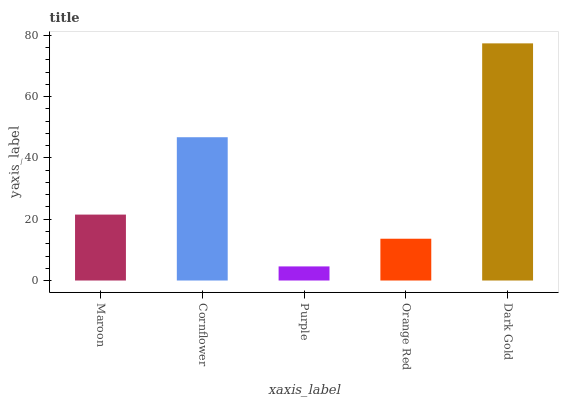Is Purple the minimum?
Answer yes or no. Yes. Is Dark Gold the maximum?
Answer yes or no. Yes. Is Cornflower the minimum?
Answer yes or no. No. Is Cornflower the maximum?
Answer yes or no. No. Is Cornflower greater than Maroon?
Answer yes or no. Yes. Is Maroon less than Cornflower?
Answer yes or no. Yes. Is Maroon greater than Cornflower?
Answer yes or no. No. Is Cornflower less than Maroon?
Answer yes or no. No. Is Maroon the high median?
Answer yes or no. Yes. Is Maroon the low median?
Answer yes or no. Yes. Is Purple the high median?
Answer yes or no. No. Is Orange Red the low median?
Answer yes or no. No. 